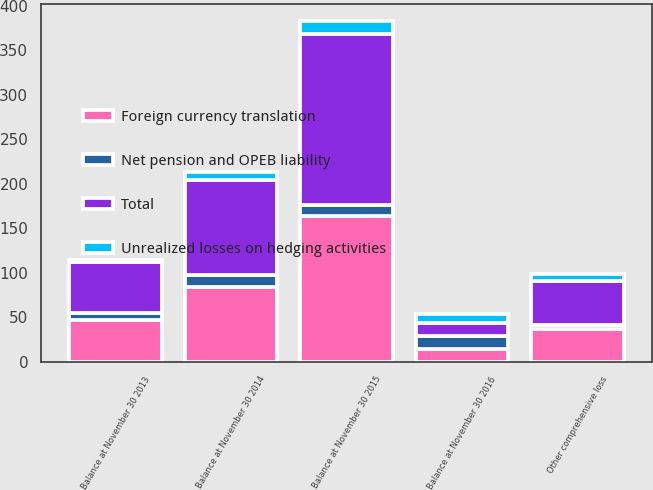Convert chart to OTSL. <chart><loc_0><loc_0><loc_500><loc_500><stacked_bar_chart><ecel><fcel>Balance at November 30 2013<fcel>Other comprehensive loss<fcel>Balance at November 30 2014<fcel>Balance at November 30 2015<fcel>Balance at November 30 2016<nl><fcel>Foreign currency translation<fcel>46.6<fcel>37<fcel>83.6<fcel>163.5<fcel>14.5<nl><fcel>Net pension and OPEB liability<fcel>8.2<fcel>4.1<fcel>13.6<fcel>13.1<fcel>14.4<nl><fcel>Unrealized losses on hedging activities<fcel>2.2<fcel>8.4<fcel>9.5<fcel>14.6<fcel>10.5<nl><fcel>Total<fcel>57<fcel>49.5<fcel>106.7<fcel>191.2<fcel>14.5<nl></chart> 